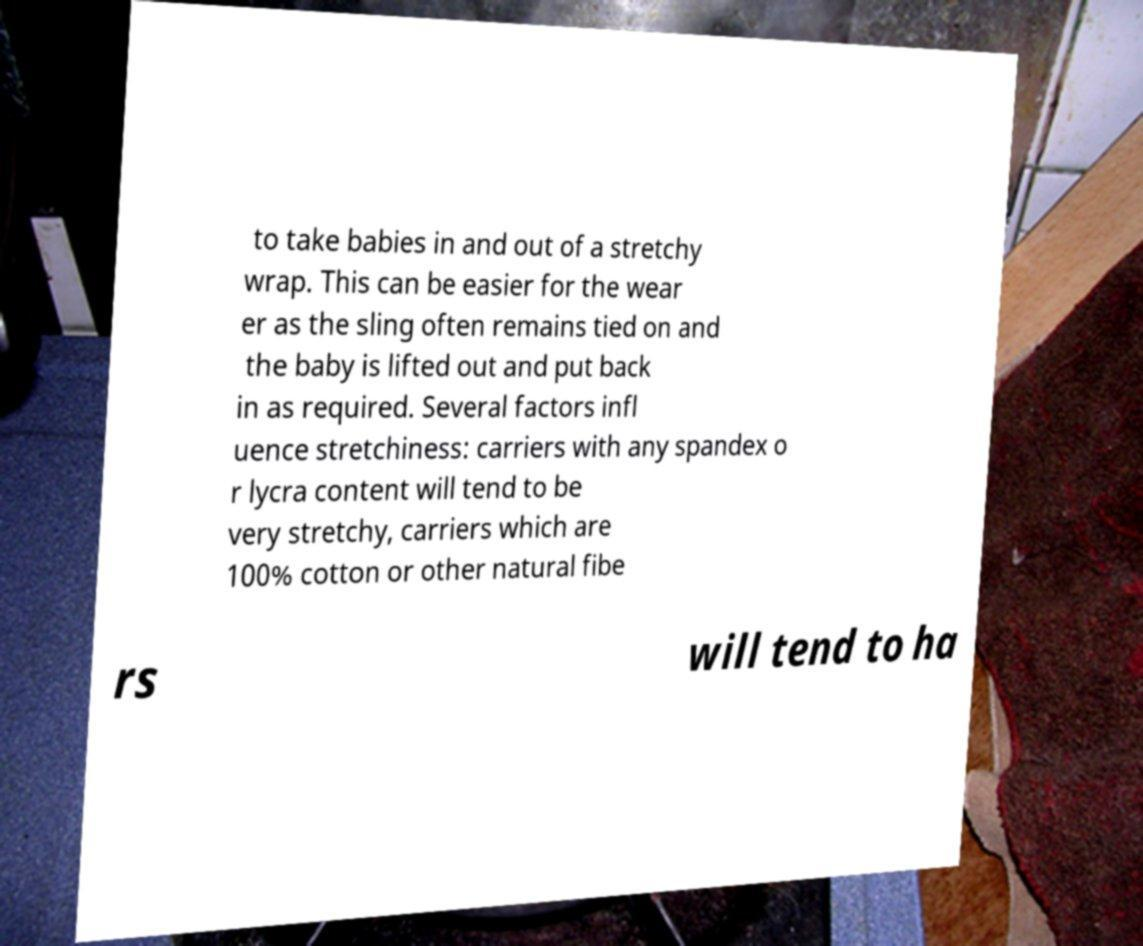What messages or text are displayed in this image? I need them in a readable, typed format. to take babies in and out of a stretchy wrap. This can be easier for the wear er as the sling often remains tied on and the baby is lifted out and put back in as required. Several factors infl uence stretchiness: carriers with any spandex o r lycra content will tend to be very stretchy, carriers which are 100% cotton or other natural fibe rs will tend to ha 